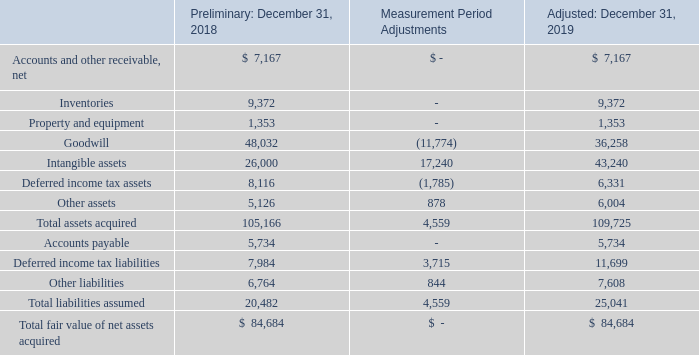ADVANCED ENERGY INDUSTRIES, INC.
NOTES TO CONSOLIDATED FINANCIAL STATEMENTS – (continued)
(in thousands, except per share amounts)
In 2019, Advanced Energy finalized the assessment of fair value for the assets acquired and liabilities assumed related to the LumaSense acquisition. The following table summarizes the fair values of the assets acquired and liabilities assumed from the LumaSense acquisition, including measurement period adjustments.
During 2019, we adjusted the estimated values of the assets acquired and liabilities assumed based upon the final valuation report. These adjustments included additional liabilities, changes to deferred taxes and changes in the allocation of excess purchase price between goodwill and intangibles.
What did the company's adjustment to the estimated values of the assets acquired and liabilities assumed  in 2019 include? Additional liabilities, changes to deferred taxes and changes in the allocation of excess purchase price between goodwill and intangibles. What was the Preliminary fair value of inventories in 2018?
Answer scale should be: thousand. 9,372. What was the Adjusted fair value of Goodwill in 2019?
Answer scale should be: thousand. 36,258. What was the percentage change in the fair value of Goodwill between 2018 and 2019?
Answer scale should be: percent. (36,258-48,032)/48,032
Answer: -24.51. What was the percentage change in the fair value of intangible assets between 2018 and 2019?
Answer scale should be: percent. (43,240-26,000)/26,000
Answer: 66.31. What was the percentage change in the fair value of deferred income tax assets between 2018 and 2019?
Answer scale should be: percent. (6,331-8,116)/8,116
Answer: -21.99. 